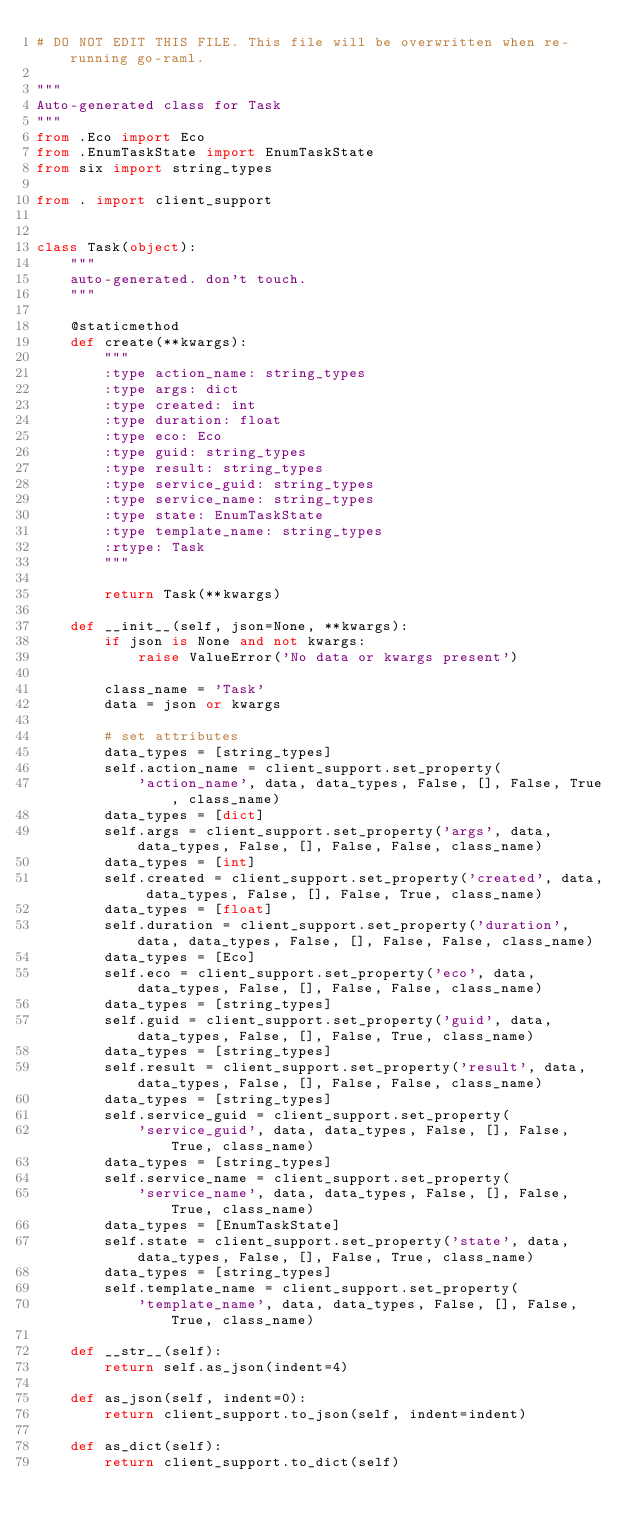Convert code to text. <code><loc_0><loc_0><loc_500><loc_500><_Python_># DO NOT EDIT THIS FILE. This file will be overwritten when re-running go-raml.

"""
Auto-generated class for Task
"""
from .Eco import Eco
from .EnumTaskState import EnumTaskState
from six import string_types

from . import client_support


class Task(object):
    """
    auto-generated. don't touch.
    """

    @staticmethod
    def create(**kwargs):
        """
        :type action_name: string_types
        :type args: dict
        :type created: int
        :type duration: float
        :type eco: Eco
        :type guid: string_types
        :type result: string_types
        :type service_guid: string_types
        :type service_name: string_types
        :type state: EnumTaskState
        :type template_name: string_types
        :rtype: Task
        """

        return Task(**kwargs)

    def __init__(self, json=None, **kwargs):
        if json is None and not kwargs:
            raise ValueError('No data or kwargs present')

        class_name = 'Task'
        data = json or kwargs

        # set attributes
        data_types = [string_types]
        self.action_name = client_support.set_property(
            'action_name', data, data_types, False, [], False, True, class_name)
        data_types = [dict]
        self.args = client_support.set_property('args', data, data_types, False, [], False, False, class_name)
        data_types = [int]
        self.created = client_support.set_property('created', data, data_types, False, [], False, True, class_name)
        data_types = [float]
        self.duration = client_support.set_property('duration', data, data_types, False, [], False, False, class_name)
        data_types = [Eco]
        self.eco = client_support.set_property('eco', data, data_types, False, [], False, False, class_name)
        data_types = [string_types]
        self.guid = client_support.set_property('guid', data, data_types, False, [], False, True, class_name)
        data_types = [string_types]
        self.result = client_support.set_property('result', data, data_types, False, [], False, False, class_name)
        data_types = [string_types]
        self.service_guid = client_support.set_property(
            'service_guid', data, data_types, False, [], False, True, class_name)
        data_types = [string_types]
        self.service_name = client_support.set_property(
            'service_name', data, data_types, False, [], False, True, class_name)
        data_types = [EnumTaskState]
        self.state = client_support.set_property('state', data, data_types, False, [], False, True, class_name)
        data_types = [string_types]
        self.template_name = client_support.set_property(
            'template_name', data, data_types, False, [], False, True, class_name)

    def __str__(self):
        return self.as_json(indent=4)

    def as_json(self, indent=0):
        return client_support.to_json(self, indent=indent)

    def as_dict(self):
        return client_support.to_dict(self)
</code> 